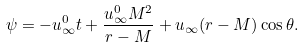Convert formula to latex. <formula><loc_0><loc_0><loc_500><loc_500>\psi = - u _ { \infty } ^ { 0 } t + \frac { u _ { \infty } ^ { 0 } M ^ { 2 } } { r - M } + u _ { \infty } ( r - M ) \cos \theta .</formula> 